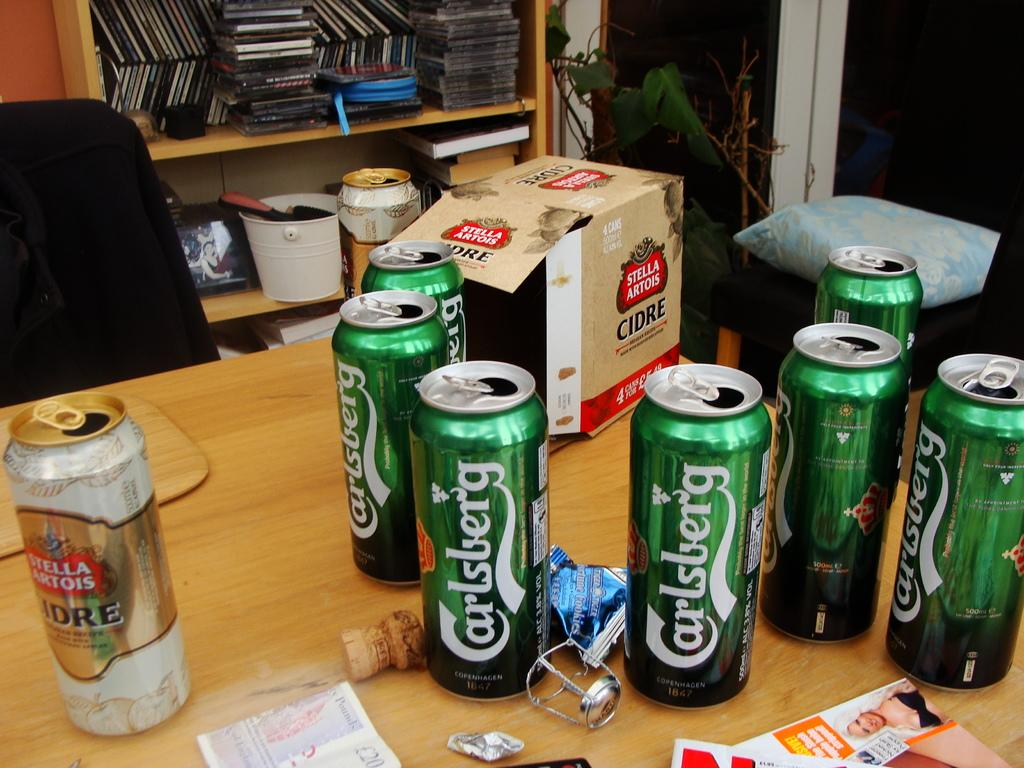<image>
Relay a brief, clear account of the picture shown. Several cans of Carlsberg are grouped on a wooden table. 